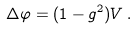Convert formula to latex. <formula><loc_0><loc_0><loc_500><loc_500>\Delta \varphi = ( 1 - g ^ { 2 } ) V \, .</formula> 